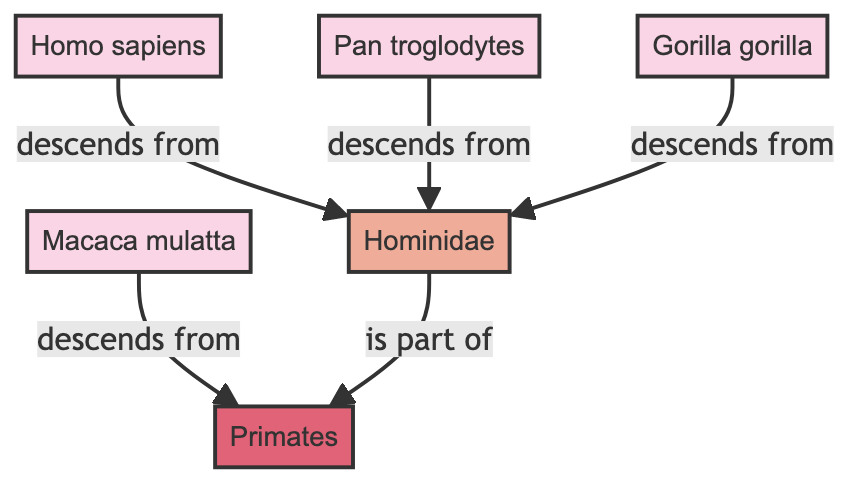What species is indicated as descending from Hominidae? The directed edges show that both Homo sapiens, Pan troglodytes, and Gorilla gorilla descend from Hominidae. Therefore, any of these species is correct.
Answer: Homo sapiens, Pan troglodytes, Gorilla gorilla How many species are shown in the graph? The nodes list indicates four species: Homo sapiens, Pan troglodytes, Gorilla gorilla, and Macaca mulatta. So, by counting these nodes, we find there are four species.
Answer: 4 What family is associated with the species Homo sapiens? The directed edge from Homo sapiens to Hominidae clearly shows that Homo sapiens belongs to the family Hominidae. Thus, Hominidae is the associated family.
Answer: Hominidae Which species is a member of the order Primates? The directed graph indicates that both Hominidae and Macaca mulatta are associated with Primates; however, the specific question asks for the species that is a member of the order, which includes Macaca mulatta directly linking to Primates.
Answer: Macaca mulatta What type of relationship exists between Hominidae and Primates? The directed edge from Hominidae to Primates, labeled "is part of," indicates that Hominidae is part of the order Primates. Thus, the relationship is hierarchical and indicates inclusion.
Answer: is part of How many edges are present in the diagram? By analyzing the edges provided, we find there are a total of five directed edges, each representing a relationship between nodes. Thus, the number of edges is five.
Answer: 5 Which species does not descend from Hominidae? The node Macaca mulatta has a directed edge down to Primates, indicating it descends from Primates and not from Hominidae. Therefore, in this directed graph, Macaca mulatta does not descend from Hominidae.
Answer: Macaca mulatta What is the relationship direction from Hominidae to Primates? The directed edge from Hominidae to Primates is labeled "is part of," which indicates the flow of the relationship goes from Hominidae towards Primates. Thus, the direction is one of inclusion.
Answer: is part of Which species has the most direct evolutionary path in the graph? The species Macaca mulatta has a direct path leading down to Primates, while the other species have paths diverging from Hominidae. By analyzing the graph, it's clear that Macaca mulatta has the most direct evolutionary path.
Answer: Macaca mulatta 